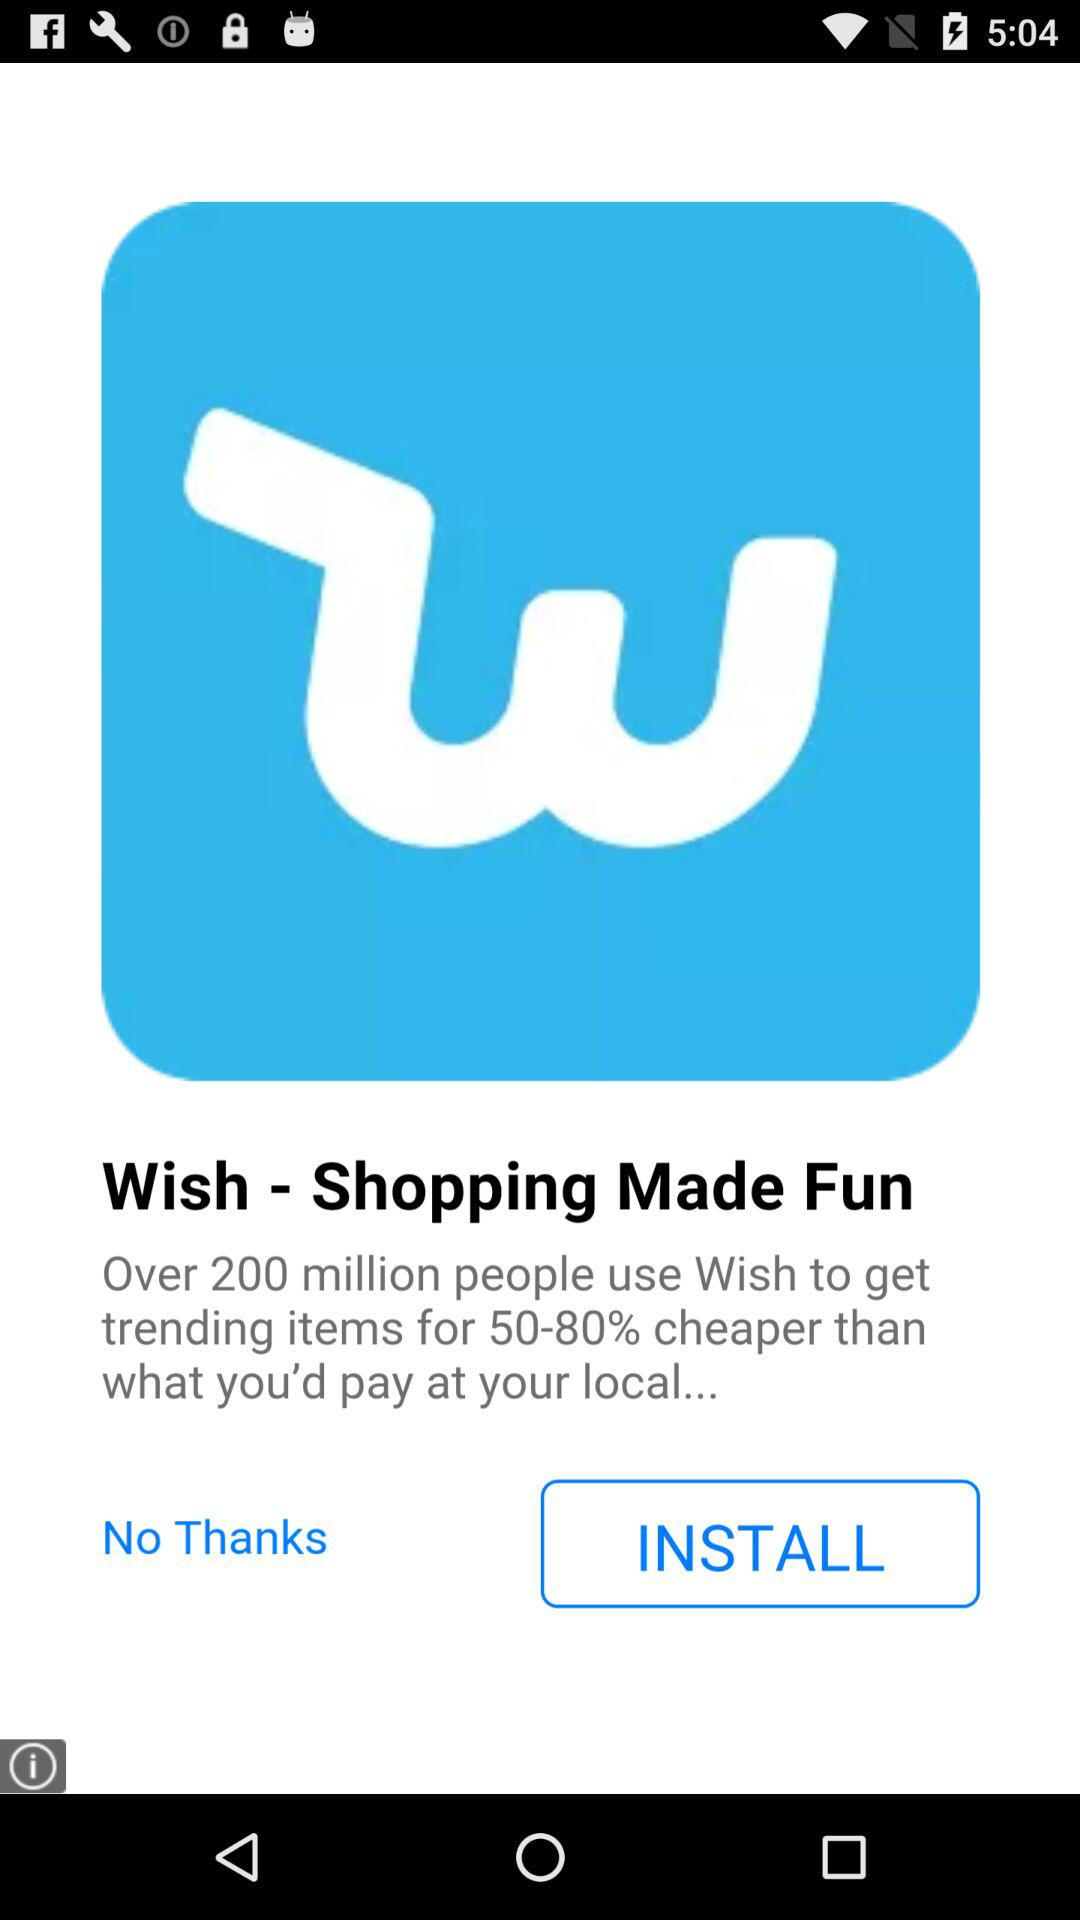How many people are using the "Wish" application to shop? The "Wish" application is being used by over 200 million people. 